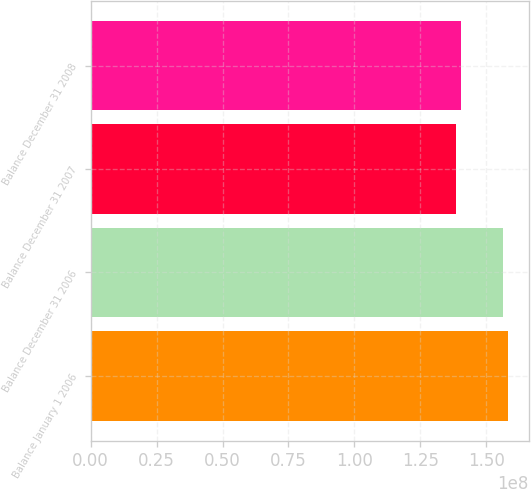Convert chart to OTSL. <chart><loc_0><loc_0><loc_500><loc_500><bar_chart><fcel>Balance January 1 2006<fcel>Balance December 31 2006<fcel>Balance December 31 2007<fcel>Balance December 31 2008<nl><fcel>1.5812e+08<fcel>1.56319e+08<fcel>1.38596e+08<fcel>1.40397e+08<nl></chart> 